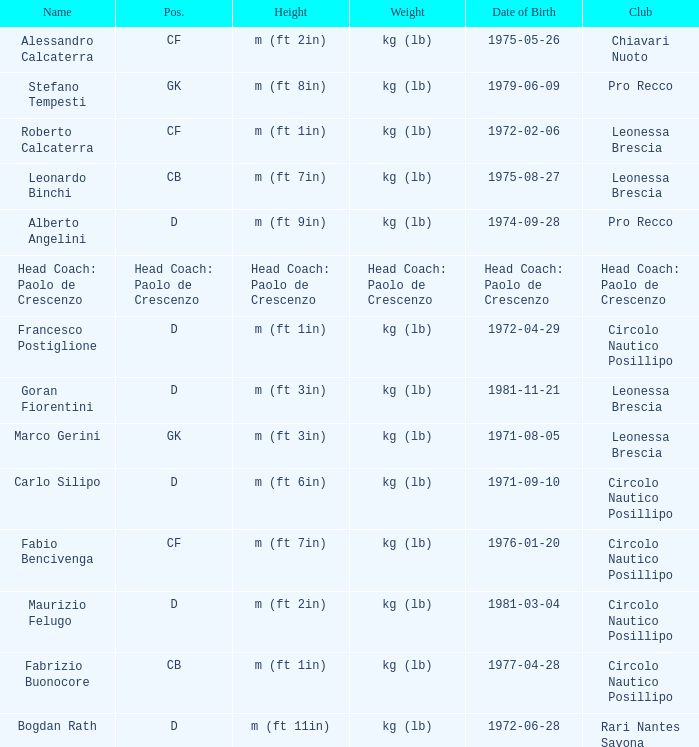What is the position of the player with a height of m (ft 6in)? D. 